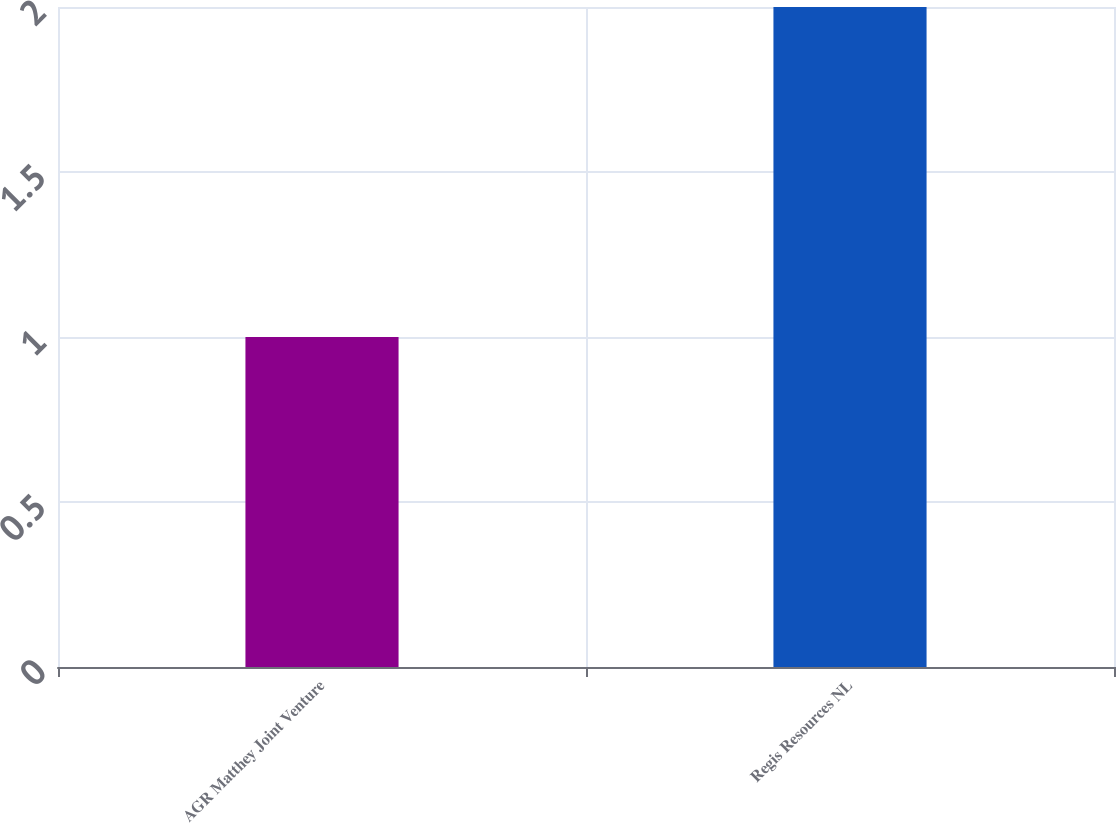<chart> <loc_0><loc_0><loc_500><loc_500><bar_chart><fcel>AGR Matthey Joint Venture<fcel>Regis Resources NL<nl><fcel>1<fcel>2<nl></chart> 